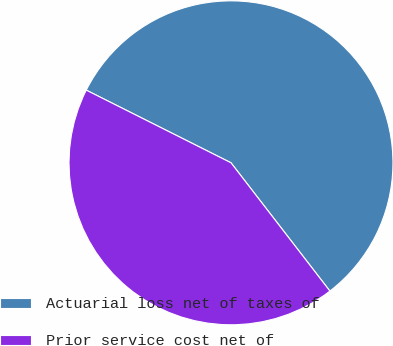<chart> <loc_0><loc_0><loc_500><loc_500><pie_chart><fcel>Actuarial loss net of taxes of<fcel>Prior service cost net of<nl><fcel>57.14%<fcel>42.86%<nl></chart> 